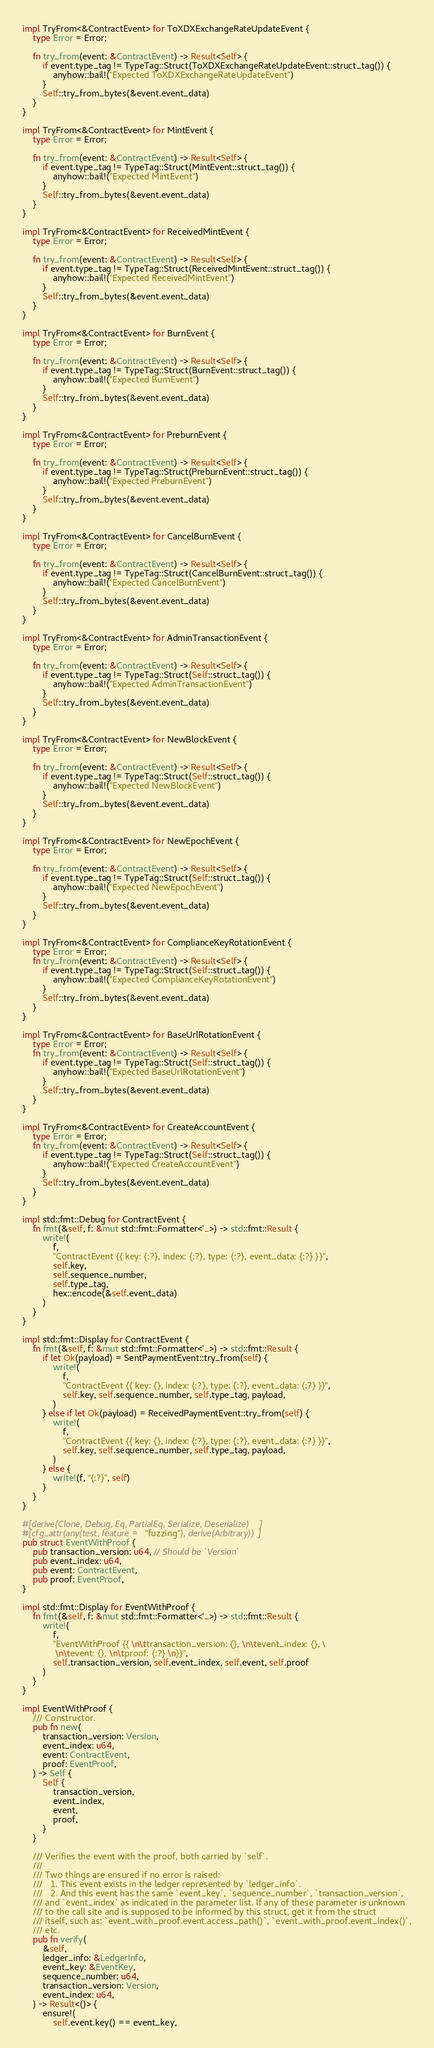<code> <loc_0><loc_0><loc_500><loc_500><_Rust_>
impl TryFrom<&ContractEvent> for ToXDXExchangeRateUpdateEvent {
    type Error = Error;

    fn try_from(event: &ContractEvent) -> Result<Self> {
        if event.type_tag != TypeTag::Struct(ToXDXExchangeRateUpdateEvent::struct_tag()) {
            anyhow::bail!("Expected ToXDXExchangeRateUpdateEvent")
        }
        Self::try_from_bytes(&event.event_data)
    }
}

impl TryFrom<&ContractEvent> for MintEvent {
    type Error = Error;

    fn try_from(event: &ContractEvent) -> Result<Self> {
        if event.type_tag != TypeTag::Struct(MintEvent::struct_tag()) {
            anyhow::bail!("Expected MintEvent")
        }
        Self::try_from_bytes(&event.event_data)
    }
}

impl TryFrom<&ContractEvent> for ReceivedMintEvent {
    type Error = Error;

    fn try_from(event: &ContractEvent) -> Result<Self> {
        if event.type_tag != TypeTag::Struct(ReceivedMintEvent::struct_tag()) {
            anyhow::bail!("Expected ReceivedMintEvent")
        }
        Self::try_from_bytes(&event.event_data)
    }
}

impl TryFrom<&ContractEvent> for BurnEvent {
    type Error = Error;

    fn try_from(event: &ContractEvent) -> Result<Self> {
        if event.type_tag != TypeTag::Struct(BurnEvent::struct_tag()) {
            anyhow::bail!("Expected BurnEvent")
        }
        Self::try_from_bytes(&event.event_data)
    }
}

impl TryFrom<&ContractEvent> for PreburnEvent {
    type Error = Error;

    fn try_from(event: &ContractEvent) -> Result<Self> {
        if event.type_tag != TypeTag::Struct(PreburnEvent::struct_tag()) {
            anyhow::bail!("Expected PreburnEvent")
        }
        Self::try_from_bytes(&event.event_data)
    }
}

impl TryFrom<&ContractEvent> for CancelBurnEvent {
    type Error = Error;

    fn try_from(event: &ContractEvent) -> Result<Self> {
        if event.type_tag != TypeTag::Struct(CancelBurnEvent::struct_tag()) {
            anyhow::bail!("Expected CancelBurnEvent")
        }
        Self::try_from_bytes(&event.event_data)
    }
}

impl TryFrom<&ContractEvent> for AdminTransactionEvent {
    type Error = Error;

    fn try_from(event: &ContractEvent) -> Result<Self> {
        if event.type_tag != TypeTag::Struct(Self::struct_tag()) {
            anyhow::bail!("Expected AdminTransactionEvent")
        }
        Self::try_from_bytes(&event.event_data)
    }
}

impl TryFrom<&ContractEvent> for NewBlockEvent {
    type Error = Error;

    fn try_from(event: &ContractEvent) -> Result<Self> {
        if event.type_tag != TypeTag::Struct(Self::struct_tag()) {
            anyhow::bail!("Expected NewBlockEvent")
        }
        Self::try_from_bytes(&event.event_data)
    }
}

impl TryFrom<&ContractEvent> for NewEpochEvent {
    type Error = Error;

    fn try_from(event: &ContractEvent) -> Result<Self> {
        if event.type_tag != TypeTag::Struct(Self::struct_tag()) {
            anyhow::bail!("Expected NewEpochEvent")
        }
        Self::try_from_bytes(&event.event_data)
    }
}

impl TryFrom<&ContractEvent> for ComplianceKeyRotationEvent {
    type Error = Error;
    fn try_from(event: &ContractEvent) -> Result<Self> {
        if event.type_tag != TypeTag::Struct(Self::struct_tag()) {
            anyhow::bail!("Expected ComplianceKeyRotationEvent")
        }
        Self::try_from_bytes(&event.event_data)
    }
}

impl TryFrom<&ContractEvent> for BaseUrlRotationEvent {
    type Error = Error;
    fn try_from(event: &ContractEvent) -> Result<Self> {
        if event.type_tag != TypeTag::Struct(Self::struct_tag()) {
            anyhow::bail!("Expected BaseUrlRotationEvent")
        }
        Self::try_from_bytes(&event.event_data)
    }
}

impl TryFrom<&ContractEvent> for CreateAccountEvent {
    type Error = Error;
    fn try_from(event: &ContractEvent) -> Result<Self> {
        if event.type_tag != TypeTag::Struct(Self::struct_tag()) {
            anyhow::bail!("Expected CreateAccountEvent")
        }
        Self::try_from_bytes(&event.event_data)
    }
}

impl std::fmt::Debug for ContractEvent {
    fn fmt(&self, f: &mut std::fmt::Formatter<'_>) -> std::fmt::Result {
        write!(
            f,
            "ContractEvent {{ key: {:?}, index: {:?}, type: {:?}, event_data: {:?} }}",
            self.key,
            self.sequence_number,
            self.type_tag,
            hex::encode(&self.event_data)
        )
    }
}

impl std::fmt::Display for ContractEvent {
    fn fmt(&self, f: &mut std::fmt::Formatter<'_>) -> std::fmt::Result {
        if let Ok(payload) = SentPaymentEvent::try_from(self) {
            write!(
                f,
                "ContractEvent {{ key: {}, index: {:?}, type: {:?}, event_data: {:?} }}",
                self.key, self.sequence_number, self.type_tag, payload,
            )
        } else if let Ok(payload) = ReceivedPaymentEvent::try_from(self) {
            write!(
                f,
                "ContractEvent {{ key: {}, index: {:?}, type: {:?}, event_data: {:?} }}",
                self.key, self.sequence_number, self.type_tag, payload,
            )
        } else {
            write!(f, "{:?}", self)
        }
    }
}

#[derive(Clone, Debug, Eq, PartialEq, Serialize, Deserialize)]
#[cfg_attr(any(test, feature = "fuzzing"), derive(Arbitrary))]
pub struct EventWithProof {
    pub transaction_version: u64, // Should be `Version`
    pub event_index: u64,
    pub event: ContractEvent,
    pub proof: EventProof,
}

impl std::fmt::Display for EventWithProof {
    fn fmt(&self, f: &mut std::fmt::Formatter<'_>) -> std::fmt::Result {
        write!(
            f,
            "EventWithProof {{ \n\ttransaction_version: {}, \n\tevent_index: {}, \
             \n\tevent: {}, \n\tproof: {:?} \n}}",
            self.transaction_version, self.event_index, self.event, self.proof
        )
    }
}

impl EventWithProof {
    /// Constructor.
    pub fn new(
        transaction_version: Version,
        event_index: u64,
        event: ContractEvent,
        proof: EventProof,
    ) -> Self {
        Self {
            transaction_version,
            event_index,
            event,
            proof,
        }
    }

    /// Verifies the event with the proof, both carried by `self`.
    ///
    /// Two things are ensured if no error is raised:
    ///   1. This event exists in the ledger represented by `ledger_info`.
    ///   2. And this event has the same `event_key`, `sequence_number`, `transaction_version`,
    /// and `event_index` as indicated in the parameter list. If any of these parameter is unknown
    /// to the call site and is supposed to be informed by this struct, get it from the struct
    /// itself, such as: `event_with_proof.event.access_path()`, `event_with_proof.event_index()`,
    /// etc.
    pub fn verify(
        &self,
        ledger_info: &LedgerInfo,
        event_key: &EventKey,
        sequence_number: u64,
        transaction_version: Version,
        event_index: u64,
    ) -> Result<()> {
        ensure!(
            self.event.key() == event_key,</code> 